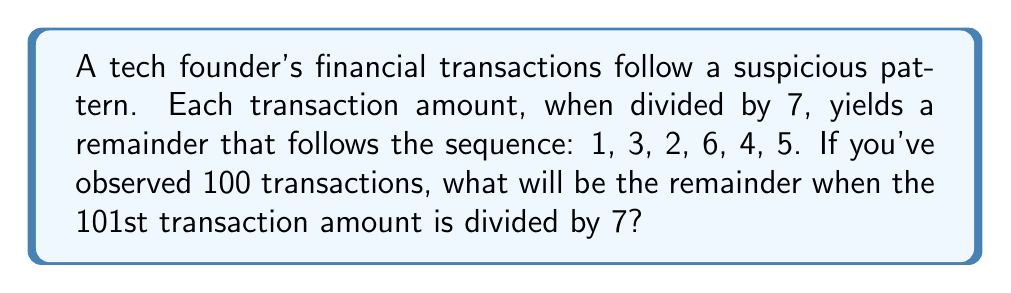Can you solve this math problem? Let's approach this step-by-step:

1) The given sequence of remainders (1, 3, 2, 6, 4, 5) repeats cyclically. This is a property of modular arithmetic.

2) To find the length of the cycle, we count the number of elements: 6.

3) We can represent this mathematically as:
   $$T_n \equiv R_n \pmod{7}$$
   where $T_n$ is the nth transaction amount, and $R_n$ is the remainder in the sequence.

4) To find the remainder for the 101st transaction, we need to determine its position in the cycle:
   $$101 \equiv r \pmod{6}$$

5) We can calculate this:
   $$101 = 16 \times 6 + 5$$

6) So, $r = 5$. This means the 101st transaction corresponds to the 5th position in our remainder sequence.

7) Looking at our original sequence (1, 3, 2, 6, 4, 5), the 5th element is 4.

Therefore, the 101st transaction amount, when divided by 7, will yield a remainder of 4.
Answer: 4 